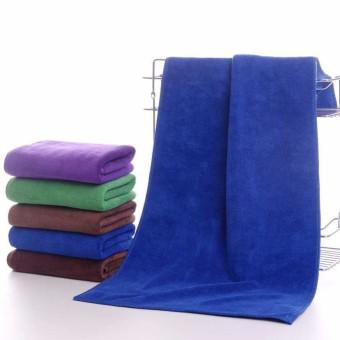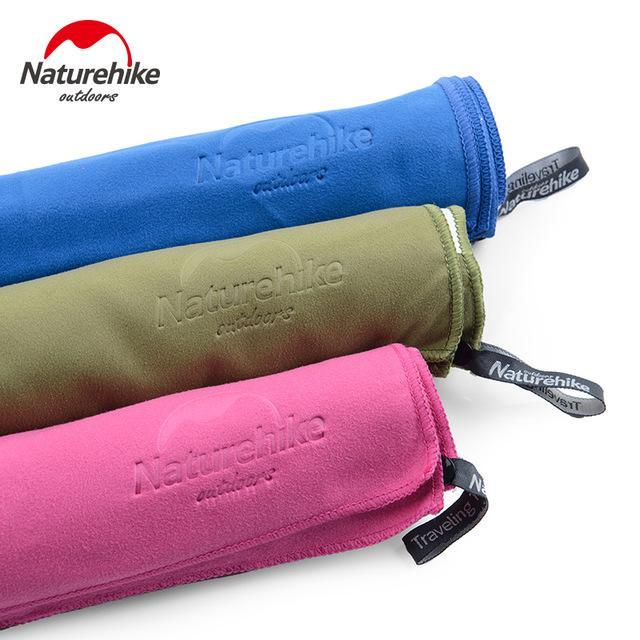The first image is the image on the left, the second image is the image on the right. Given the left and right images, does the statement "In the image on the left the there is an orange towel at the top of a stack of towels." hold true? Answer yes or no. No. The first image is the image on the left, the second image is the image on the right. For the images displayed, is the sentence "In one image, a pink towel is draped over and around a single stack of seven or fewer folded towels in various colors." factually correct? Answer yes or no. No. 